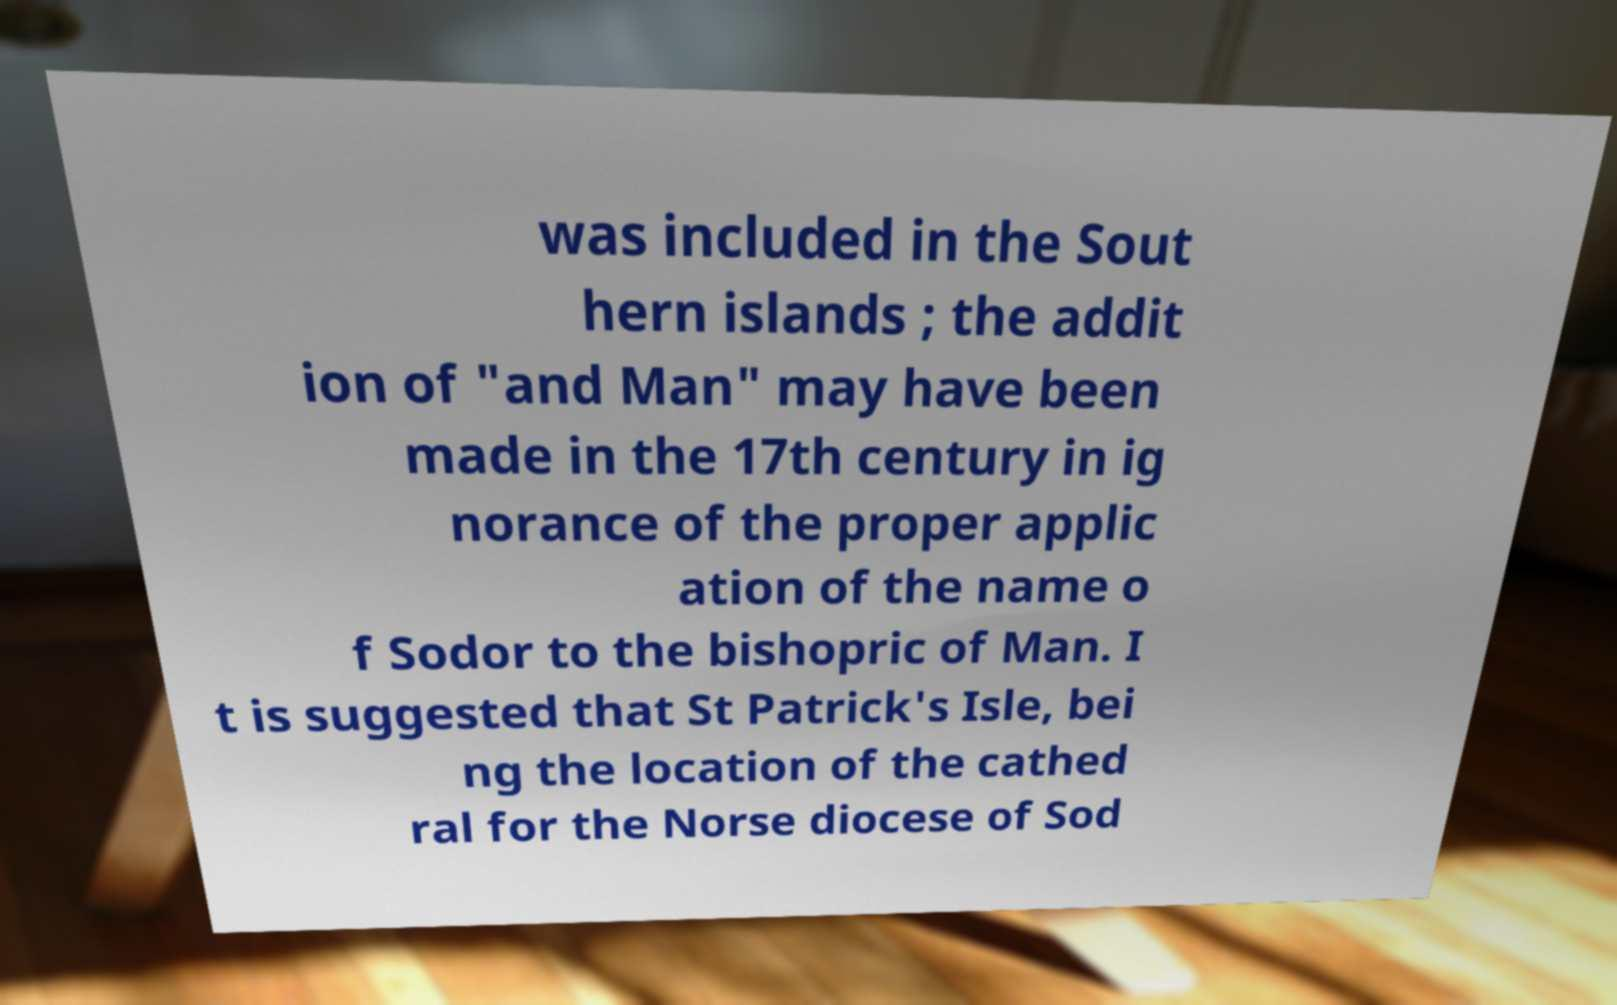What messages or text are displayed in this image? I need them in a readable, typed format. was included in the Sout hern islands ; the addit ion of "and Man" may have been made in the 17th century in ig norance of the proper applic ation of the name o f Sodor to the bishopric of Man. I t is suggested that St Patrick's Isle, bei ng the location of the cathed ral for the Norse diocese of Sod 